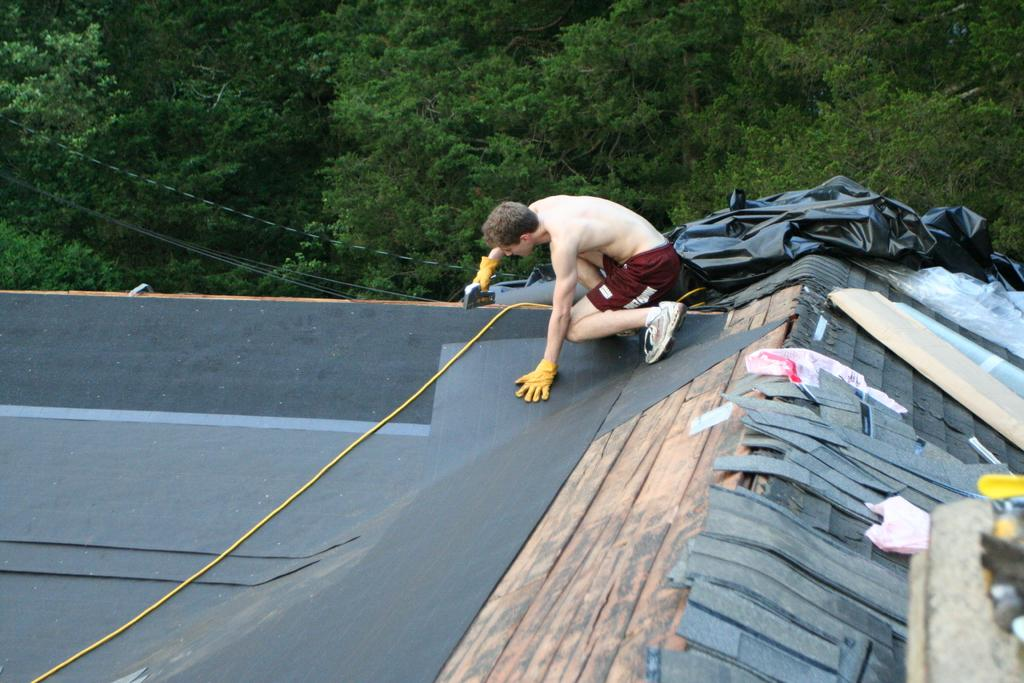What is the person in the image doing? The person is sitting on the roof of a building and using a drilling machine. What can be seen in the background of the image? There are trees visible in the image. What type of kittens can be seen playing in the church in the image? There is no church or kittens present in the image. 